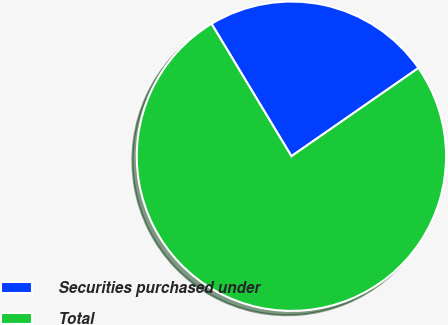<chart> <loc_0><loc_0><loc_500><loc_500><pie_chart><fcel>Securities purchased under<fcel>Total<nl><fcel>23.98%<fcel>76.02%<nl></chart> 